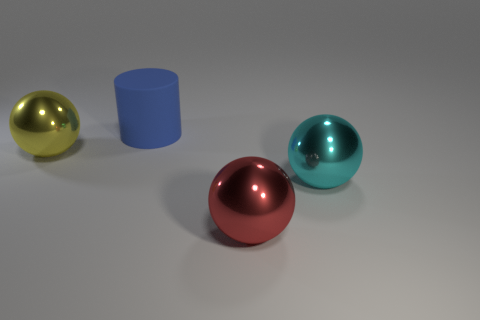Add 2 small red cubes. How many objects exist? 6 Subtract all large red balls. How many balls are left? 2 Subtract all red spheres. How many spheres are left? 2 Subtract 2 spheres. How many spheres are left? 1 Subtract all blue spheres. Subtract all blue cubes. How many spheres are left? 3 Subtract 0 cyan cylinders. How many objects are left? 4 Subtract all cylinders. How many objects are left? 3 Subtract all purple cubes. How many cyan balls are left? 1 Subtract all gray shiny cylinders. Subtract all cyan things. How many objects are left? 3 Add 1 cylinders. How many cylinders are left? 2 